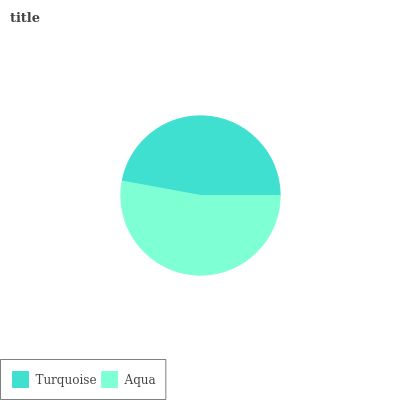Is Turquoise the minimum?
Answer yes or no. Yes. Is Aqua the maximum?
Answer yes or no. Yes. Is Aqua the minimum?
Answer yes or no. No. Is Aqua greater than Turquoise?
Answer yes or no. Yes. Is Turquoise less than Aqua?
Answer yes or no. Yes. Is Turquoise greater than Aqua?
Answer yes or no. No. Is Aqua less than Turquoise?
Answer yes or no. No. Is Aqua the high median?
Answer yes or no. Yes. Is Turquoise the low median?
Answer yes or no. Yes. Is Turquoise the high median?
Answer yes or no. No. Is Aqua the low median?
Answer yes or no. No. 